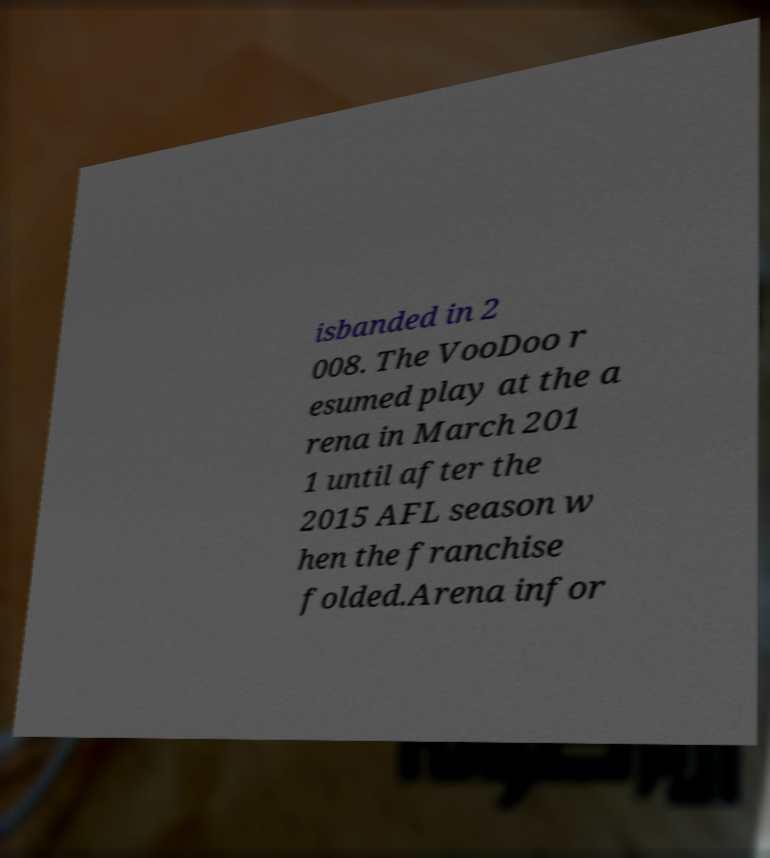Can you accurately transcribe the text from the provided image for me? isbanded in 2 008. The VooDoo r esumed play at the a rena in March 201 1 until after the 2015 AFL season w hen the franchise folded.Arena infor 